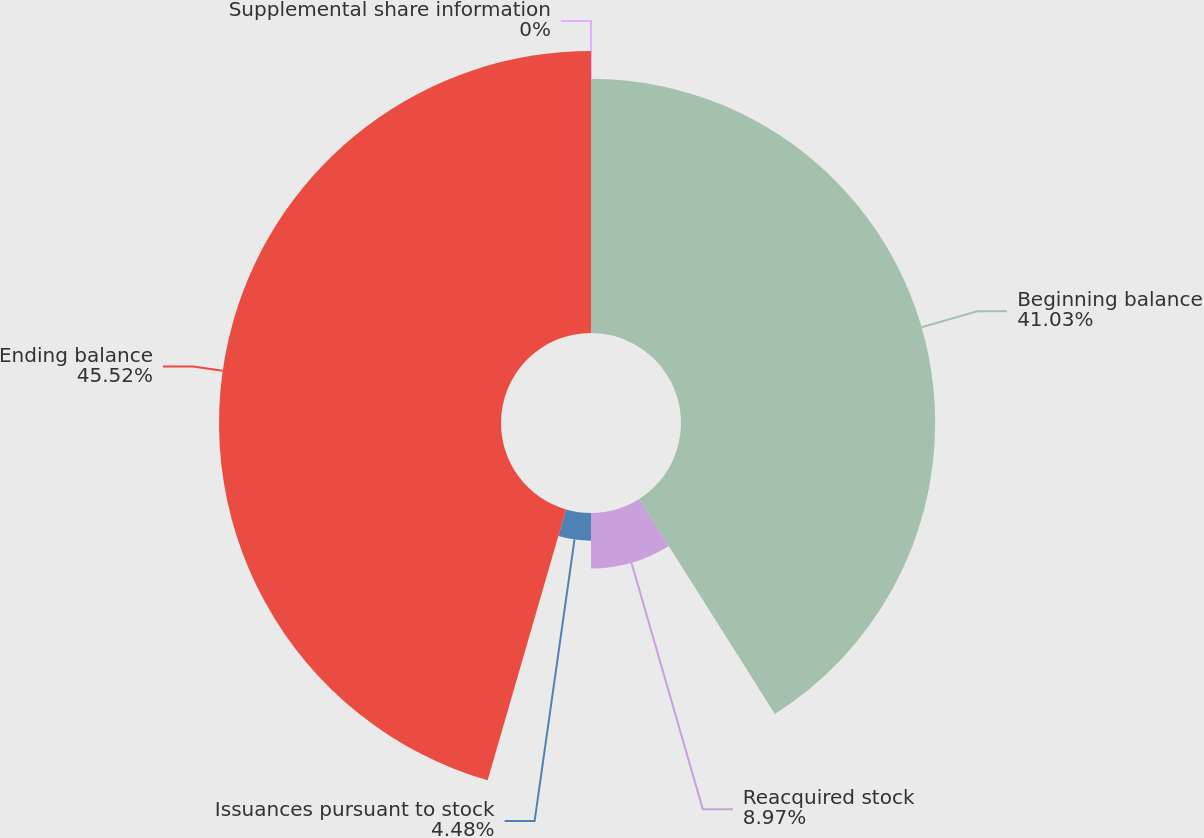<chart> <loc_0><loc_0><loc_500><loc_500><pie_chart><fcel>Supplemental share information<fcel>Beginning balance<fcel>Reacquired stock<fcel>Issuances pursuant to stock<fcel>Ending balance<nl><fcel>0.0%<fcel>41.03%<fcel>8.97%<fcel>4.48%<fcel>45.52%<nl></chart> 